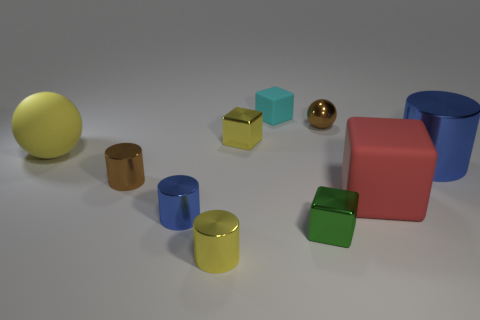There is a tiny yellow block that is behind the big shiny cylinder; what number of small things are behind it?
Provide a succinct answer. 2. Are there fewer tiny brown metal objects in front of the large red matte thing than big rubber spheres behind the large rubber sphere?
Give a very brief answer. No. There is a blue thing that is left of the shiny block that is to the right of the tiny yellow cube; what shape is it?
Offer a very short reply. Cylinder. How many other objects are there of the same material as the tiny sphere?
Offer a terse response. 6. Is there any other thing that has the same size as the green metal object?
Give a very brief answer. Yes. Are there more small purple things than red rubber cubes?
Provide a succinct answer. No. There is a blue metallic cylinder that is in front of the metallic cylinder that is behind the small metallic cylinder to the left of the small blue object; what is its size?
Your response must be concise. Small. Does the yellow rubber object have the same size as the brown metal thing that is right of the small yellow metal cylinder?
Your answer should be very brief. No. Are there fewer big red cubes that are left of the tiny metal sphere than small metallic cylinders?
Make the answer very short. Yes. What number of shiny blocks are the same color as the large sphere?
Provide a succinct answer. 1. 